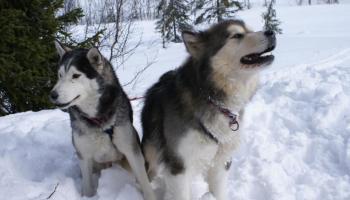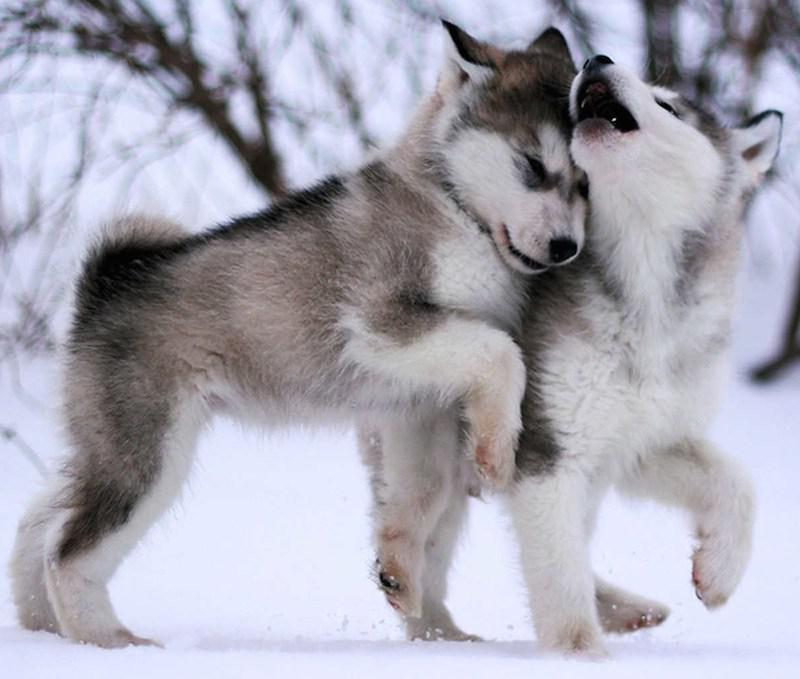The first image is the image on the left, the second image is the image on the right. Considering the images on both sides, is "There are two dogs with light colored eyes." valid? Answer yes or no. No. The first image is the image on the left, the second image is the image on the right. Evaluate the accuracy of this statement regarding the images: "Each image contains one prominent camera-gazing husky dog with blue eyes and a closed mouth.". Is it true? Answer yes or no. No. 